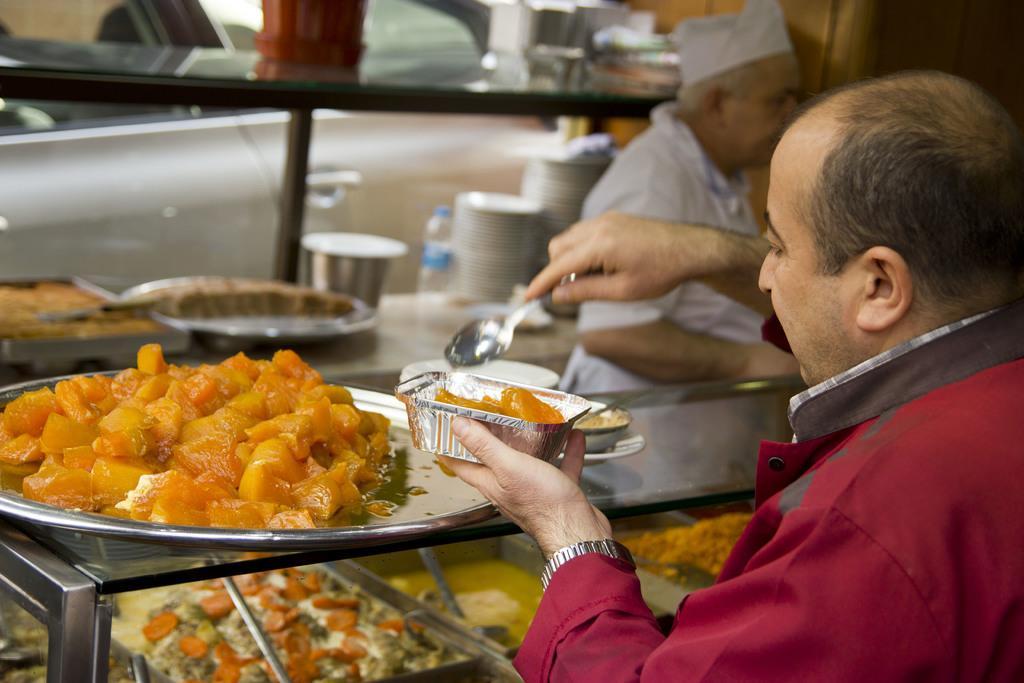Describe this image in one or two sentences. In this image we can see a person. He is wearing maroon color shirt and holding spoon and box in his hand. In front of him sweet dish is there. Background of the image one more man is there and one rack is there. In rack, plate, bottle and containers are present. 